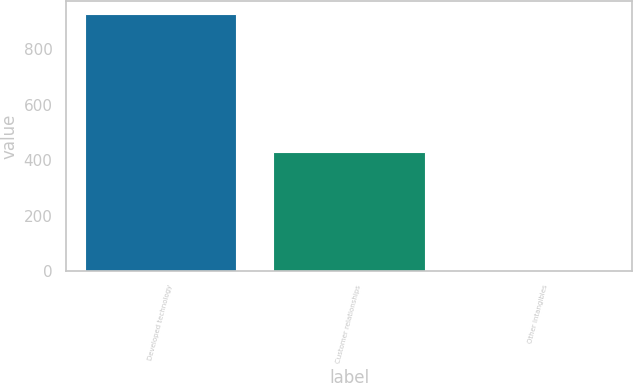Convert chart. <chart><loc_0><loc_0><loc_500><loc_500><bar_chart><fcel>Developed technology<fcel>Customer relationships<fcel>Other intangibles<nl><fcel>928<fcel>431<fcel>2<nl></chart> 